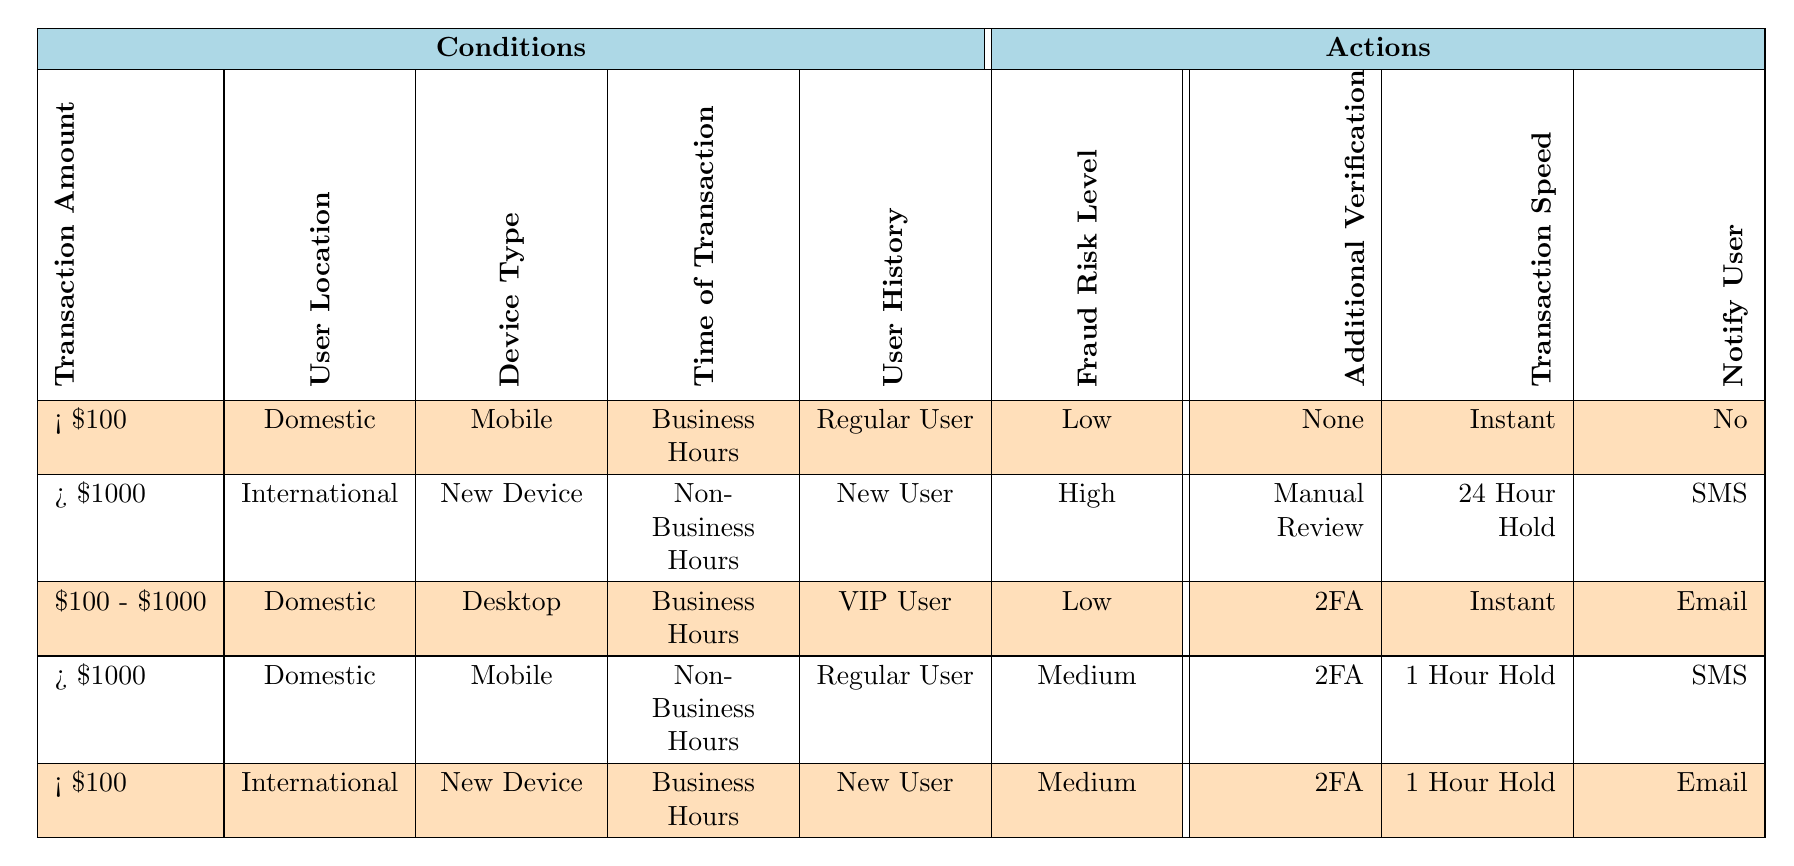What is the fraud risk level for transactions over $1000 from international new users using a new device during non-business hours? The rules indicate that for this case, the fraud risk level is classified as High based on the specific conditions outlined in the second rule of the table.
Answer: High How many different user history types are listed in the table? The table lists three types of user history: New User, Regular User, and VIP User. Thus, there are three distinct user history types.
Answer: 3 Is additional verification required for transactions under $100 from international new users during business hours? According to the relevant rule in the table, additional verification is required (2FA) for this transaction scenario, indicating a need for verification.
Answer: Yes What transaction speeds are associated with medium fraud risk levels? The relevant rows indicate that transactions with medium risk levels have a transaction speed of either 1 Hour Hold or Instant. Specifically, one entry denotes 1 Hour Hold and the other could either be 1 Hour Hold or Instant.
Answer: 1 Hour Hold, Instant For domestic transactions over $1000 made on mobile devices by regular users during non-business hours, what action is taken regarding notifying the user? The rule specifies that for this scenario, users are notified via SMS. This aligns with the defined parameters within the table.
Answer: SMS What is the percentage of rules that indicate a low fraud risk level? There are three rules in total that classify transactions as Low risk (first and third rules). Hence, to find the percentage: (3/5) * 100 = 60%.
Answer: 60% Are there any conditions where transactions under $100 from international new users during business hours do not require additional verification? The rules indicate that for transactions under $100 in this scenario, additional verification is required (2FA), meaning that no cases exist without it.
Answer: No Which device type is associated with the highest fraud risk level listed in the table? The device type associated with the highest risk level is 'New Device,' as indicated by the rule that specifies high fraud risk for this condition among others.
Answer: New Device What combination of conditions leads to a low fraud risk when the transaction amount is between $100 and $1000? For this transaction amount, a low fraud risk is achieved when the user is Domestic, uses a Desktop device, and is categorized as a VIP User, per the relevant rule.
Answer: Domestic, Desktop, VIP User 